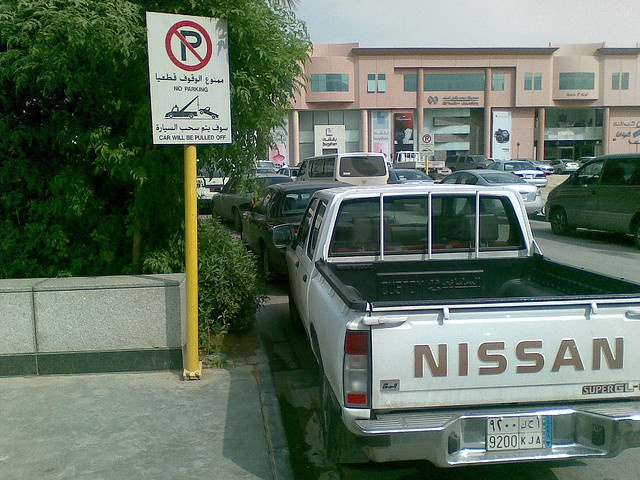Describe the objects in this image and their specific colors. I can see truck in olive, black, gray, lightgray, and darkgray tones, car in olive, black, darkgreen, and teal tones, car in olive, black, gray, darkgreen, and purple tones, car in olive, gray, darkgray, black, and purple tones, and car in olive, black, darkgreen, teal, and purple tones in this image. 